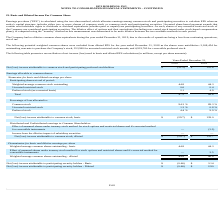According to Hc2 Holdings's financial document, How is Earning Per Share (EPS) calculated? calculated using the two-class method, which allocates earnings among common stock and participating securities to calculate EPS when an entity's capital structure includes either two or more classes of common stock or common stock and participating securities.. The document states: "Earnings per share ("EPS") is calculated using the two-class method, which allocates earnings among common stock and participating securities to calcu..." Also, What was the Net (loss) income attributable to common stock and participating preferred stockholders in 2018? According to the financial document, $155.6 (in millions). The relevant text states: "d participating preferred stockholders $ (31.5) $ 155.6..." Also, What was the Net (loss) income attributable to common stock and participating preferred stockholders in 2019? According to the financial document, $(31.5) (in millions). The relevant text states: "n stock and participating preferred stockholders $ (31.5) $ 155.6..." Also, can you calculate: What is the change in the Weighted-average common basic stock outstanding from 2018 to 2019? Based on the calculation: 44.8 - 44.3, the result is 0.5 (in millions). This is based on the information: "Weighted-average common stock outstanding 44.8 44.3 Weighted-average common stock outstanding 44.8 44.3..." The key data points involved are: 44.3, 44.8. Also, can you calculate: What is the average unvested restricted stock for 2018 and 2019? To answer this question, I need to perform calculations using the financial data. The calculation is: (0.6 + 0.4) / 2, which equals 0.5 (in millions). This is based on the information: "Unvested restricted stock 0.6 0.4 Unvested restricted stock 0.6 0.4..." The key data points involved are: 0.4, 0.6. Also, can you calculate: What was the average Preferred stock (as-converted basis) for 2018 and 2019? To answer this question, I need to perform calculations using the financial data. The calculation is: (2.1 + 4.9) / 2, which equals 3.5 (in millions). This is based on the information: "Preferred stock (as-converted basis) 2.1 4.9 Preferred stock (as-converted basis) 2.1 4.9..." The key data points involved are: 2.1, 4.9. 